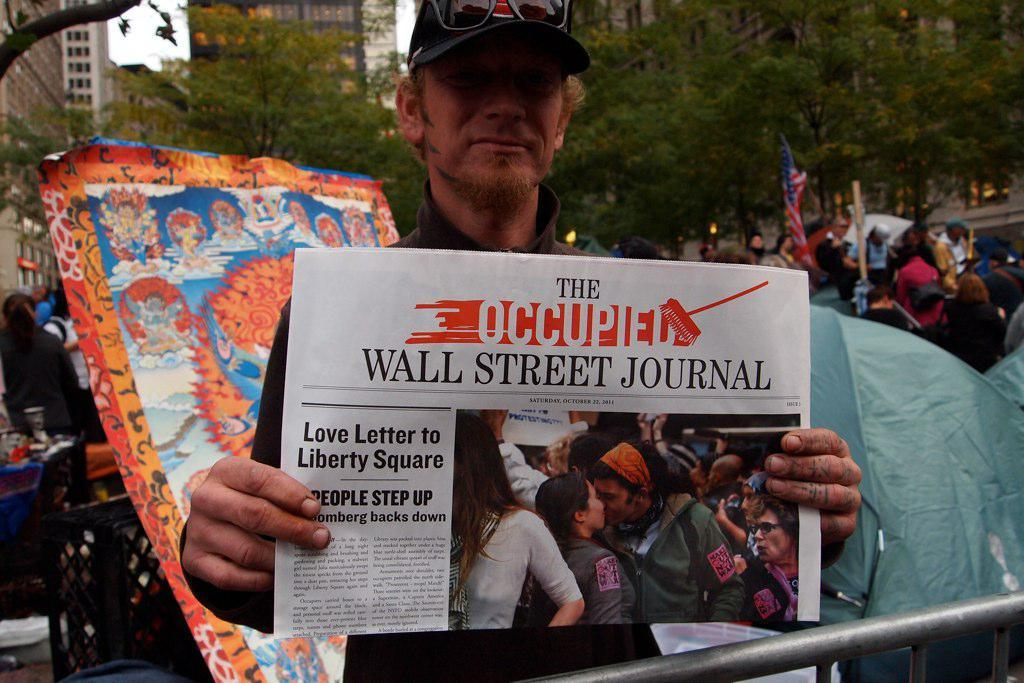<image>
Summarize the visual content of the image. An individual is holding up a newspaper titled "The Occupied Wall Street Journal" with a lead story of "Love Letter to Liberty Square." 